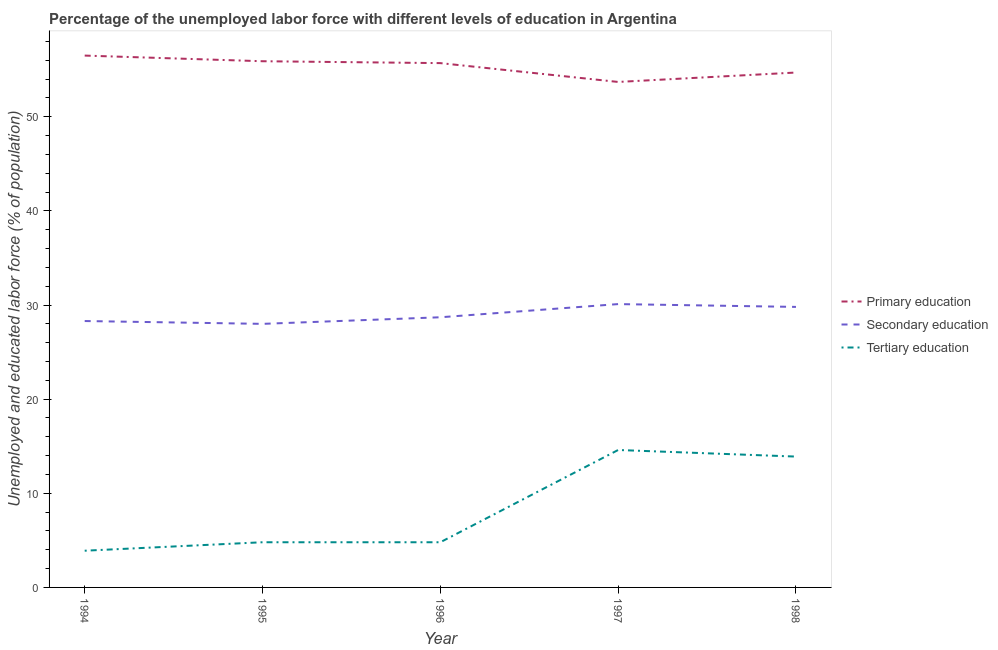What is the percentage of labor force who received tertiary education in 1998?
Give a very brief answer. 13.9. Across all years, what is the maximum percentage of labor force who received primary education?
Ensure brevity in your answer.  56.5. Across all years, what is the minimum percentage of labor force who received primary education?
Keep it short and to the point. 53.7. What is the total percentage of labor force who received tertiary education in the graph?
Your response must be concise. 42. What is the difference between the percentage of labor force who received tertiary education in 1995 and that in 1997?
Ensure brevity in your answer.  -9.8. What is the difference between the percentage of labor force who received tertiary education in 1997 and the percentage of labor force who received primary education in 1996?
Ensure brevity in your answer.  -41.1. What is the average percentage of labor force who received tertiary education per year?
Offer a very short reply. 8.4. In the year 1995, what is the difference between the percentage of labor force who received primary education and percentage of labor force who received secondary education?
Provide a short and direct response. 27.9. In how many years, is the percentage of labor force who received tertiary education greater than 10 %?
Your answer should be compact. 2. What is the ratio of the percentage of labor force who received tertiary education in 1996 to that in 1997?
Offer a very short reply. 0.33. What is the difference between the highest and the second highest percentage of labor force who received secondary education?
Your response must be concise. 0.3. What is the difference between the highest and the lowest percentage of labor force who received tertiary education?
Make the answer very short. 10.7. In how many years, is the percentage of labor force who received secondary education greater than the average percentage of labor force who received secondary education taken over all years?
Offer a very short reply. 2. Is the sum of the percentage of labor force who received secondary education in 1994 and 1996 greater than the maximum percentage of labor force who received tertiary education across all years?
Your response must be concise. Yes. Is it the case that in every year, the sum of the percentage of labor force who received primary education and percentage of labor force who received secondary education is greater than the percentage of labor force who received tertiary education?
Provide a succinct answer. Yes. Does the percentage of labor force who received tertiary education monotonically increase over the years?
Offer a very short reply. No. Is the percentage of labor force who received primary education strictly greater than the percentage of labor force who received secondary education over the years?
Give a very brief answer. Yes. Is the percentage of labor force who received primary education strictly less than the percentage of labor force who received secondary education over the years?
Your answer should be compact. No. Are the values on the major ticks of Y-axis written in scientific E-notation?
Provide a succinct answer. No. Where does the legend appear in the graph?
Keep it short and to the point. Center right. How many legend labels are there?
Your answer should be compact. 3. How are the legend labels stacked?
Make the answer very short. Vertical. What is the title of the graph?
Give a very brief answer. Percentage of the unemployed labor force with different levels of education in Argentina. What is the label or title of the X-axis?
Make the answer very short. Year. What is the label or title of the Y-axis?
Offer a terse response. Unemployed and educated labor force (% of population). What is the Unemployed and educated labor force (% of population) in Primary education in 1994?
Provide a succinct answer. 56.5. What is the Unemployed and educated labor force (% of population) of Secondary education in 1994?
Make the answer very short. 28.3. What is the Unemployed and educated labor force (% of population) in Tertiary education in 1994?
Provide a succinct answer. 3.9. What is the Unemployed and educated labor force (% of population) in Primary education in 1995?
Offer a terse response. 55.9. What is the Unemployed and educated labor force (% of population) in Tertiary education in 1995?
Provide a short and direct response. 4.8. What is the Unemployed and educated labor force (% of population) of Primary education in 1996?
Offer a terse response. 55.7. What is the Unemployed and educated labor force (% of population) in Secondary education in 1996?
Provide a succinct answer. 28.7. What is the Unemployed and educated labor force (% of population) in Tertiary education in 1996?
Offer a very short reply. 4.8. What is the Unemployed and educated labor force (% of population) of Primary education in 1997?
Your answer should be very brief. 53.7. What is the Unemployed and educated labor force (% of population) of Secondary education in 1997?
Provide a succinct answer. 30.1. What is the Unemployed and educated labor force (% of population) in Tertiary education in 1997?
Offer a terse response. 14.6. What is the Unemployed and educated labor force (% of population) in Primary education in 1998?
Offer a terse response. 54.7. What is the Unemployed and educated labor force (% of population) in Secondary education in 1998?
Provide a succinct answer. 29.8. What is the Unemployed and educated labor force (% of population) of Tertiary education in 1998?
Offer a terse response. 13.9. Across all years, what is the maximum Unemployed and educated labor force (% of population) in Primary education?
Offer a terse response. 56.5. Across all years, what is the maximum Unemployed and educated labor force (% of population) of Secondary education?
Provide a short and direct response. 30.1. Across all years, what is the maximum Unemployed and educated labor force (% of population) in Tertiary education?
Offer a very short reply. 14.6. Across all years, what is the minimum Unemployed and educated labor force (% of population) of Primary education?
Offer a very short reply. 53.7. Across all years, what is the minimum Unemployed and educated labor force (% of population) in Secondary education?
Give a very brief answer. 28. Across all years, what is the minimum Unemployed and educated labor force (% of population) of Tertiary education?
Offer a very short reply. 3.9. What is the total Unemployed and educated labor force (% of population) of Primary education in the graph?
Keep it short and to the point. 276.5. What is the total Unemployed and educated labor force (% of population) in Secondary education in the graph?
Offer a very short reply. 144.9. What is the total Unemployed and educated labor force (% of population) in Tertiary education in the graph?
Keep it short and to the point. 42. What is the difference between the Unemployed and educated labor force (% of population) of Secondary education in 1994 and that in 1995?
Your response must be concise. 0.3. What is the difference between the Unemployed and educated labor force (% of population) of Primary education in 1994 and that in 1996?
Provide a succinct answer. 0.8. What is the difference between the Unemployed and educated labor force (% of population) of Primary education in 1994 and that in 1997?
Provide a short and direct response. 2.8. What is the difference between the Unemployed and educated labor force (% of population) in Secondary education in 1994 and that in 1997?
Provide a succinct answer. -1.8. What is the difference between the Unemployed and educated labor force (% of population) in Primary education in 1994 and that in 1998?
Offer a very short reply. 1.8. What is the difference between the Unemployed and educated labor force (% of population) in Secondary education in 1994 and that in 1998?
Offer a very short reply. -1.5. What is the difference between the Unemployed and educated labor force (% of population) of Tertiary education in 1994 and that in 1998?
Your answer should be compact. -10. What is the difference between the Unemployed and educated labor force (% of population) in Primary education in 1995 and that in 1996?
Make the answer very short. 0.2. What is the difference between the Unemployed and educated labor force (% of population) in Tertiary education in 1995 and that in 1996?
Offer a terse response. 0. What is the difference between the Unemployed and educated labor force (% of population) of Secondary education in 1995 and that in 1998?
Your answer should be very brief. -1.8. What is the difference between the Unemployed and educated labor force (% of population) in Tertiary education in 1995 and that in 1998?
Keep it short and to the point. -9.1. What is the difference between the Unemployed and educated labor force (% of population) in Primary education in 1996 and that in 1997?
Offer a very short reply. 2. What is the difference between the Unemployed and educated labor force (% of population) of Secondary education in 1996 and that in 1997?
Your response must be concise. -1.4. What is the difference between the Unemployed and educated labor force (% of population) in Tertiary education in 1996 and that in 1997?
Keep it short and to the point. -9.8. What is the difference between the Unemployed and educated labor force (% of population) in Primary education in 1996 and that in 1998?
Give a very brief answer. 1. What is the difference between the Unemployed and educated labor force (% of population) in Secondary education in 1996 and that in 1998?
Give a very brief answer. -1.1. What is the difference between the Unemployed and educated labor force (% of population) in Tertiary education in 1996 and that in 1998?
Your response must be concise. -9.1. What is the difference between the Unemployed and educated labor force (% of population) in Secondary education in 1997 and that in 1998?
Your answer should be very brief. 0.3. What is the difference between the Unemployed and educated labor force (% of population) of Primary education in 1994 and the Unemployed and educated labor force (% of population) of Tertiary education in 1995?
Your answer should be compact. 51.7. What is the difference between the Unemployed and educated labor force (% of population) of Primary education in 1994 and the Unemployed and educated labor force (% of population) of Secondary education in 1996?
Give a very brief answer. 27.8. What is the difference between the Unemployed and educated labor force (% of population) of Primary education in 1994 and the Unemployed and educated labor force (% of population) of Tertiary education in 1996?
Your answer should be very brief. 51.7. What is the difference between the Unemployed and educated labor force (% of population) in Primary education in 1994 and the Unemployed and educated labor force (% of population) in Secondary education in 1997?
Offer a very short reply. 26.4. What is the difference between the Unemployed and educated labor force (% of population) in Primary education in 1994 and the Unemployed and educated labor force (% of population) in Tertiary education in 1997?
Offer a terse response. 41.9. What is the difference between the Unemployed and educated labor force (% of population) of Primary education in 1994 and the Unemployed and educated labor force (% of population) of Secondary education in 1998?
Your response must be concise. 26.7. What is the difference between the Unemployed and educated labor force (% of population) of Primary education in 1994 and the Unemployed and educated labor force (% of population) of Tertiary education in 1998?
Ensure brevity in your answer.  42.6. What is the difference between the Unemployed and educated labor force (% of population) in Secondary education in 1994 and the Unemployed and educated labor force (% of population) in Tertiary education in 1998?
Make the answer very short. 14.4. What is the difference between the Unemployed and educated labor force (% of population) of Primary education in 1995 and the Unemployed and educated labor force (% of population) of Secondary education in 1996?
Ensure brevity in your answer.  27.2. What is the difference between the Unemployed and educated labor force (% of population) in Primary education in 1995 and the Unemployed and educated labor force (% of population) in Tertiary education in 1996?
Ensure brevity in your answer.  51.1. What is the difference between the Unemployed and educated labor force (% of population) of Secondary education in 1995 and the Unemployed and educated labor force (% of population) of Tertiary education in 1996?
Your answer should be very brief. 23.2. What is the difference between the Unemployed and educated labor force (% of population) in Primary education in 1995 and the Unemployed and educated labor force (% of population) in Secondary education in 1997?
Provide a short and direct response. 25.8. What is the difference between the Unemployed and educated labor force (% of population) of Primary education in 1995 and the Unemployed and educated labor force (% of population) of Tertiary education in 1997?
Provide a succinct answer. 41.3. What is the difference between the Unemployed and educated labor force (% of population) in Primary education in 1995 and the Unemployed and educated labor force (% of population) in Secondary education in 1998?
Give a very brief answer. 26.1. What is the difference between the Unemployed and educated labor force (% of population) in Primary education in 1995 and the Unemployed and educated labor force (% of population) in Tertiary education in 1998?
Ensure brevity in your answer.  42. What is the difference between the Unemployed and educated labor force (% of population) of Primary education in 1996 and the Unemployed and educated labor force (% of population) of Secondary education in 1997?
Keep it short and to the point. 25.6. What is the difference between the Unemployed and educated labor force (% of population) in Primary education in 1996 and the Unemployed and educated labor force (% of population) in Tertiary education in 1997?
Keep it short and to the point. 41.1. What is the difference between the Unemployed and educated labor force (% of population) in Secondary education in 1996 and the Unemployed and educated labor force (% of population) in Tertiary education in 1997?
Provide a succinct answer. 14.1. What is the difference between the Unemployed and educated labor force (% of population) in Primary education in 1996 and the Unemployed and educated labor force (% of population) in Secondary education in 1998?
Your response must be concise. 25.9. What is the difference between the Unemployed and educated labor force (% of population) of Primary education in 1996 and the Unemployed and educated labor force (% of population) of Tertiary education in 1998?
Keep it short and to the point. 41.8. What is the difference between the Unemployed and educated labor force (% of population) of Secondary education in 1996 and the Unemployed and educated labor force (% of population) of Tertiary education in 1998?
Provide a succinct answer. 14.8. What is the difference between the Unemployed and educated labor force (% of population) in Primary education in 1997 and the Unemployed and educated labor force (% of population) in Secondary education in 1998?
Provide a succinct answer. 23.9. What is the difference between the Unemployed and educated labor force (% of population) of Primary education in 1997 and the Unemployed and educated labor force (% of population) of Tertiary education in 1998?
Offer a terse response. 39.8. What is the average Unemployed and educated labor force (% of population) of Primary education per year?
Give a very brief answer. 55.3. What is the average Unemployed and educated labor force (% of population) of Secondary education per year?
Make the answer very short. 28.98. In the year 1994, what is the difference between the Unemployed and educated labor force (% of population) of Primary education and Unemployed and educated labor force (% of population) of Secondary education?
Offer a very short reply. 28.2. In the year 1994, what is the difference between the Unemployed and educated labor force (% of population) in Primary education and Unemployed and educated labor force (% of population) in Tertiary education?
Provide a short and direct response. 52.6. In the year 1994, what is the difference between the Unemployed and educated labor force (% of population) in Secondary education and Unemployed and educated labor force (% of population) in Tertiary education?
Your answer should be compact. 24.4. In the year 1995, what is the difference between the Unemployed and educated labor force (% of population) in Primary education and Unemployed and educated labor force (% of population) in Secondary education?
Offer a terse response. 27.9. In the year 1995, what is the difference between the Unemployed and educated labor force (% of population) in Primary education and Unemployed and educated labor force (% of population) in Tertiary education?
Give a very brief answer. 51.1. In the year 1995, what is the difference between the Unemployed and educated labor force (% of population) in Secondary education and Unemployed and educated labor force (% of population) in Tertiary education?
Your answer should be compact. 23.2. In the year 1996, what is the difference between the Unemployed and educated labor force (% of population) of Primary education and Unemployed and educated labor force (% of population) of Tertiary education?
Your answer should be compact. 50.9. In the year 1996, what is the difference between the Unemployed and educated labor force (% of population) in Secondary education and Unemployed and educated labor force (% of population) in Tertiary education?
Your response must be concise. 23.9. In the year 1997, what is the difference between the Unemployed and educated labor force (% of population) of Primary education and Unemployed and educated labor force (% of population) of Secondary education?
Ensure brevity in your answer.  23.6. In the year 1997, what is the difference between the Unemployed and educated labor force (% of population) in Primary education and Unemployed and educated labor force (% of population) in Tertiary education?
Keep it short and to the point. 39.1. In the year 1998, what is the difference between the Unemployed and educated labor force (% of population) of Primary education and Unemployed and educated labor force (% of population) of Secondary education?
Your answer should be compact. 24.9. In the year 1998, what is the difference between the Unemployed and educated labor force (% of population) in Primary education and Unemployed and educated labor force (% of population) in Tertiary education?
Your answer should be very brief. 40.8. What is the ratio of the Unemployed and educated labor force (% of population) of Primary education in 1994 to that in 1995?
Provide a short and direct response. 1.01. What is the ratio of the Unemployed and educated labor force (% of population) of Secondary education in 1994 to that in 1995?
Offer a terse response. 1.01. What is the ratio of the Unemployed and educated labor force (% of population) of Tertiary education in 1994 to that in 1995?
Provide a succinct answer. 0.81. What is the ratio of the Unemployed and educated labor force (% of population) in Primary education in 1994 to that in 1996?
Give a very brief answer. 1.01. What is the ratio of the Unemployed and educated labor force (% of population) of Secondary education in 1994 to that in 1996?
Give a very brief answer. 0.99. What is the ratio of the Unemployed and educated labor force (% of population) in Tertiary education in 1994 to that in 1996?
Ensure brevity in your answer.  0.81. What is the ratio of the Unemployed and educated labor force (% of population) of Primary education in 1994 to that in 1997?
Your answer should be compact. 1.05. What is the ratio of the Unemployed and educated labor force (% of population) of Secondary education in 1994 to that in 1997?
Your response must be concise. 0.94. What is the ratio of the Unemployed and educated labor force (% of population) of Tertiary education in 1994 to that in 1997?
Offer a very short reply. 0.27. What is the ratio of the Unemployed and educated labor force (% of population) in Primary education in 1994 to that in 1998?
Make the answer very short. 1.03. What is the ratio of the Unemployed and educated labor force (% of population) in Secondary education in 1994 to that in 1998?
Offer a very short reply. 0.95. What is the ratio of the Unemployed and educated labor force (% of population) of Tertiary education in 1994 to that in 1998?
Provide a succinct answer. 0.28. What is the ratio of the Unemployed and educated labor force (% of population) of Secondary education in 1995 to that in 1996?
Provide a short and direct response. 0.98. What is the ratio of the Unemployed and educated labor force (% of population) in Primary education in 1995 to that in 1997?
Make the answer very short. 1.04. What is the ratio of the Unemployed and educated labor force (% of population) of Secondary education in 1995 to that in 1997?
Provide a succinct answer. 0.93. What is the ratio of the Unemployed and educated labor force (% of population) of Tertiary education in 1995 to that in 1997?
Offer a terse response. 0.33. What is the ratio of the Unemployed and educated labor force (% of population) of Primary education in 1995 to that in 1998?
Your response must be concise. 1.02. What is the ratio of the Unemployed and educated labor force (% of population) of Secondary education in 1995 to that in 1998?
Offer a very short reply. 0.94. What is the ratio of the Unemployed and educated labor force (% of population) in Tertiary education in 1995 to that in 1998?
Provide a succinct answer. 0.35. What is the ratio of the Unemployed and educated labor force (% of population) of Primary education in 1996 to that in 1997?
Offer a terse response. 1.04. What is the ratio of the Unemployed and educated labor force (% of population) in Secondary education in 1996 to that in 1997?
Make the answer very short. 0.95. What is the ratio of the Unemployed and educated labor force (% of population) in Tertiary education in 1996 to that in 1997?
Ensure brevity in your answer.  0.33. What is the ratio of the Unemployed and educated labor force (% of population) in Primary education in 1996 to that in 1998?
Ensure brevity in your answer.  1.02. What is the ratio of the Unemployed and educated labor force (% of population) of Secondary education in 1996 to that in 1998?
Offer a terse response. 0.96. What is the ratio of the Unemployed and educated labor force (% of population) of Tertiary education in 1996 to that in 1998?
Your answer should be very brief. 0.35. What is the ratio of the Unemployed and educated labor force (% of population) of Primary education in 1997 to that in 1998?
Keep it short and to the point. 0.98. What is the ratio of the Unemployed and educated labor force (% of population) in Tertiary education in 1997 to that in 1998?
Provide a succinct answer. 1.05. What is the difference between the highest and the second highest Unemployed and educated labor force (% of population) of Tertiary education?
Your answer should be very brief. 0.7. What is the difference between the highest and the lowest Unemployed and educated labor force (% of population) of Secondary education?
Keep it short and to the point. 2.1. 